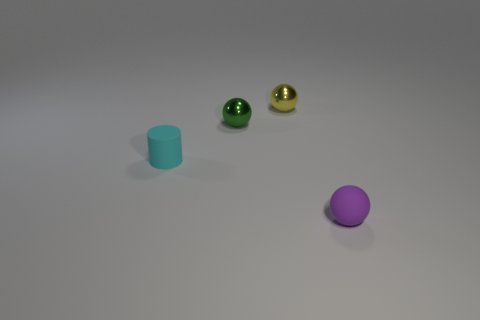Add 4 yellow things. How many objects exist? 8 Subtract all cylinders. How many objects are left? 3 Subtract 0 brown blocks. How many objects are left? 4 Subtract all metallic balls. Subtract all small yellow things. How many objects are left? 1 Add 1 small cyan rubber cylinders. How many small cyan rubber cylinders are left? 2 Add 1 tiny purple things. How many tiny purple things exist? 2 